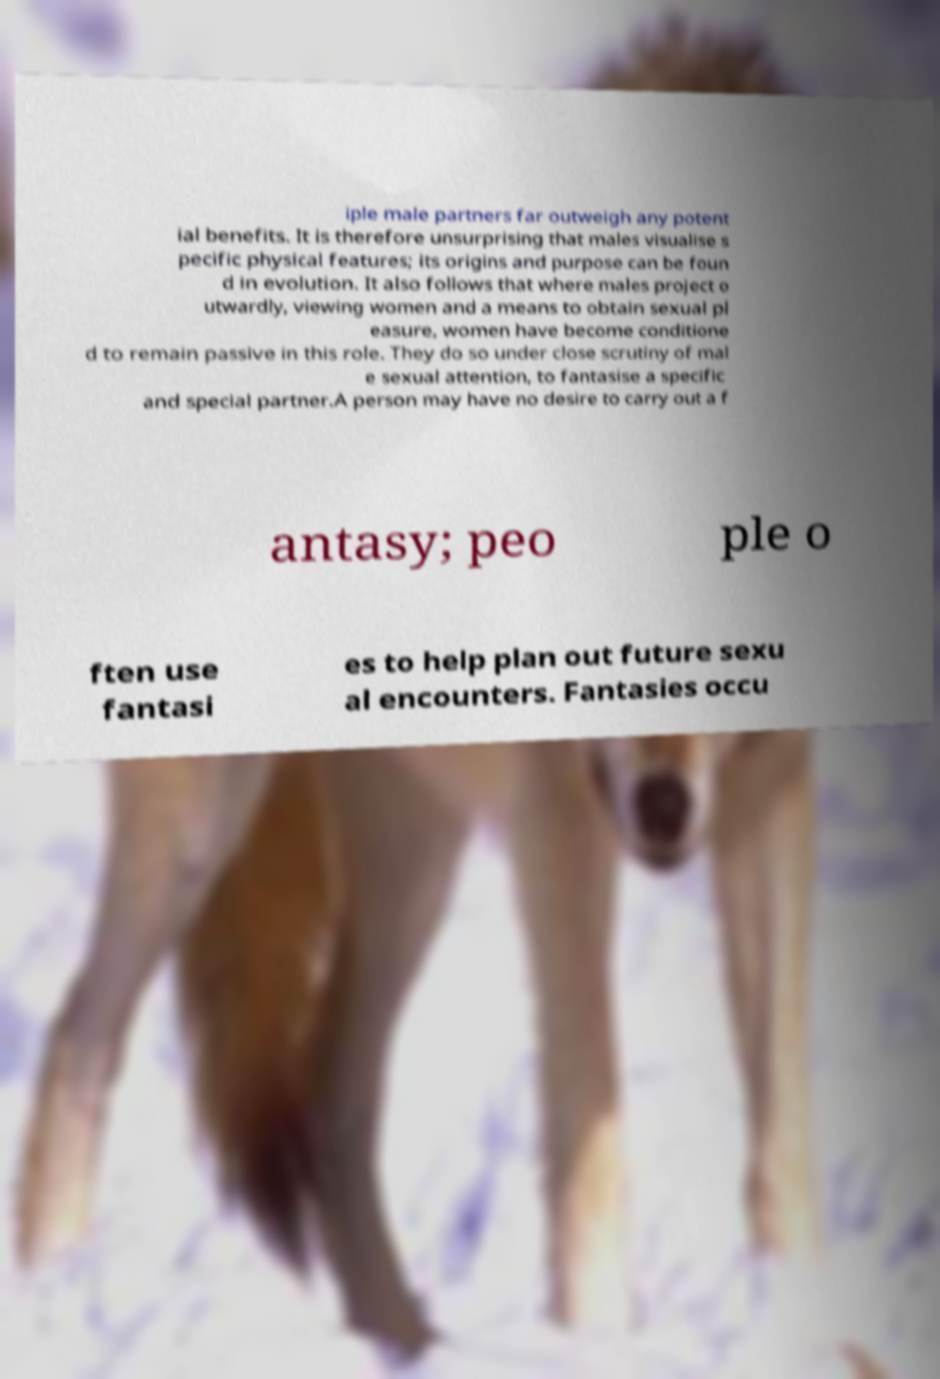Can you accurately transcribe the text from the provided image for me? iple male partners far outweigh any potent ial benefits. It is therefore unsurprising that males visualise s pecific physical features; its origins and purpose can be foun d in evolution. It also follows that where males project o utwardly, viewing women and a means to obtain sexual pl easure, women have become conditione d to remain passive in this role. They do so under close scrutiny of mal e sexual attention, to fantasise a specific and special partner.A person may have no desire to carry out a f antasy; peo ple o ften use fantasi es to help plan out future sexu al encounters. Fantasies occu 